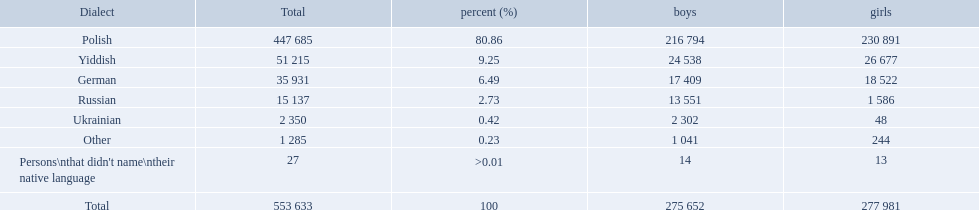What language makes a majority Polish. What the the total number of speakers? 553 633. 